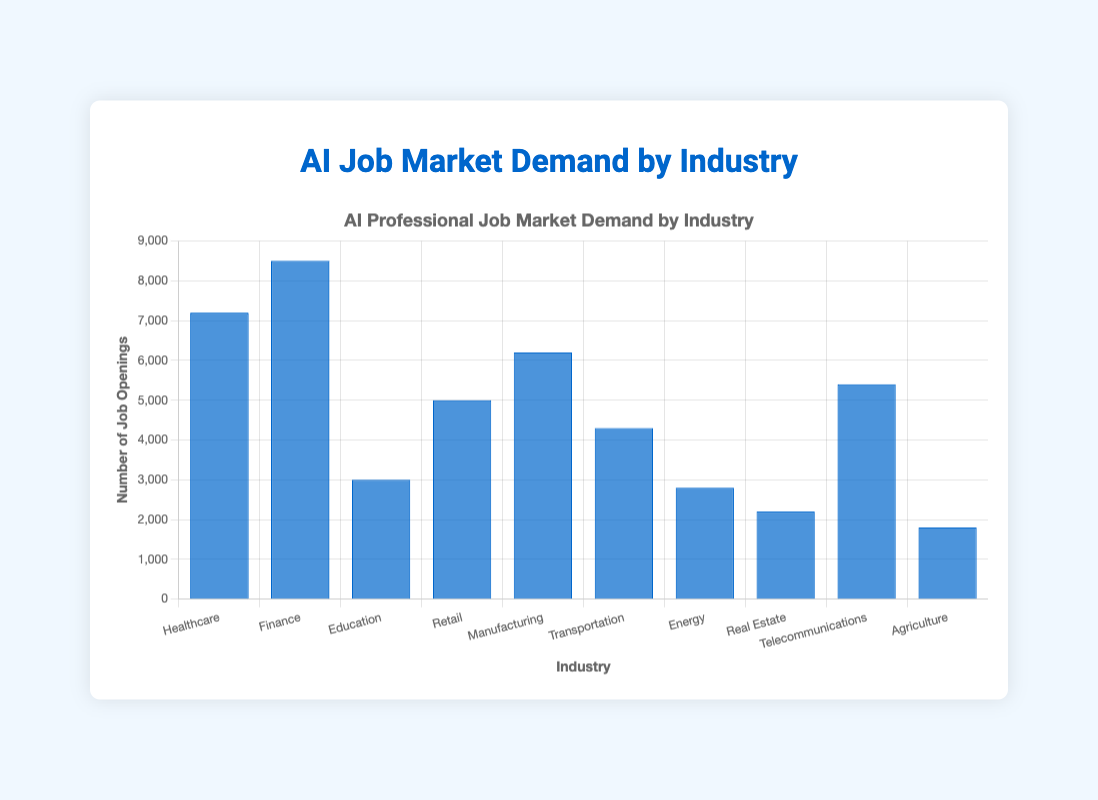What's the industry with the highest demand for AI professionals? First, look at the heights of all the bars in the figure. The bar representing Finance is the tallest, which indicates the highest demand among all industries.
Answer: Finance What's the difference in job demand between Healthcare and Retail industries? Identify the heights of the Healthcare (7200) and Retail (5000) bars. Subtract the smaller value from the larger one: 7200 - 5000.
Answer: 2200 Which industries have a demand that exceeds 5000 job openings? Observe the bars and find those whose heights are greater than 5000. These are Healthcare (7200), Finance (8500), and Manufacturing (6200).
Answer: Healthcare, Finance, Manufacturing What is the total job market demand for AI professionals across all industries? Sum the heights of all the bars: 7200 (Healthcare) + 8500 (Finance) + 3000 (Education) + 5000 (Retail) + 6200 (Manufacturing) + 4300 (Transportation) + 2800 (Energy) + 2200 (Real Estate) + 5400 (Telecommunications) + 1800 (Agriculture).
Answer: 54400 How much lower is the job demand in Agriculture compared to Telecommunications? Identify the heights of the Agriculture (1800) and Telecommunications (5400) bars. Subtract the height of Agriculture from Telecommunications: 5400 - 1800.
Answer: 3600 Which two industries have the smallest job demand, and what is their combined total? Observe and find the bars representing the smallest demands: Agriculture (1800) and Real Estate (2200). Add their values: 1800 + 2200.
Answer: Agriculture, Real Estate; 4000 By how much does the demand for AI professionals in Energy lag behind Manufacturing? Identify the heights of the Energy (2800) and Manufacturing (6200) bars. Subtract the smaller value from the larger one: 6200 - 2800.
Answer: 3400 What percentage of the total job market demand does the Finance industry represent? First, find the total job market demand (54400). Then, divide the demand in Finance (8500) by the total demand and multiply by 100 to get the percentage: (8500/54400) * 100.
Answer: 15.63% What is the average job market demand for AI professionals across the provided industries? Sum the demands across all industries (total 54400) and divide by the number of industries (10): 54400 / 10.
Answer: 5440 